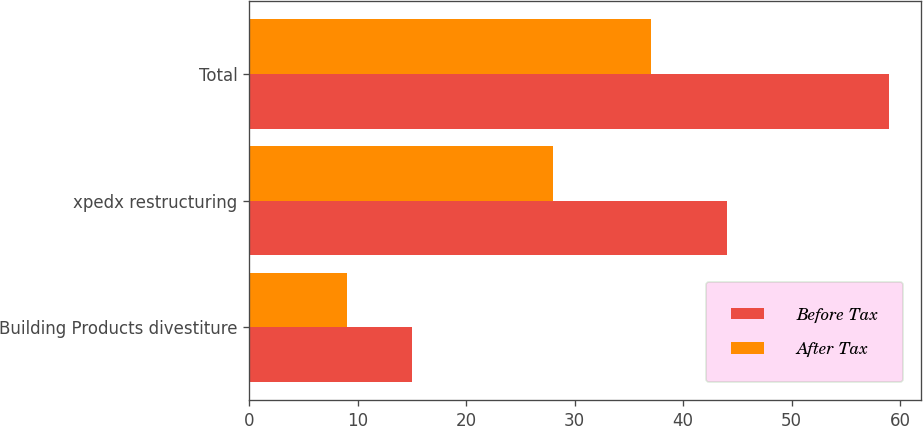Convert chart to OTSL. <chart><loc_0><loc_0><loc_500><loc_500><stacked_bar_chart><ecel><fcel>Building Products divestiture<fcel>xpedx restructuring<fcel>Total<nl><fcel>Before Tax<fcel>15<fcel>44<fcel>59<nl><fcel>After Tax<fcel>9<fcel>28<fcel>37<nl></chart> 